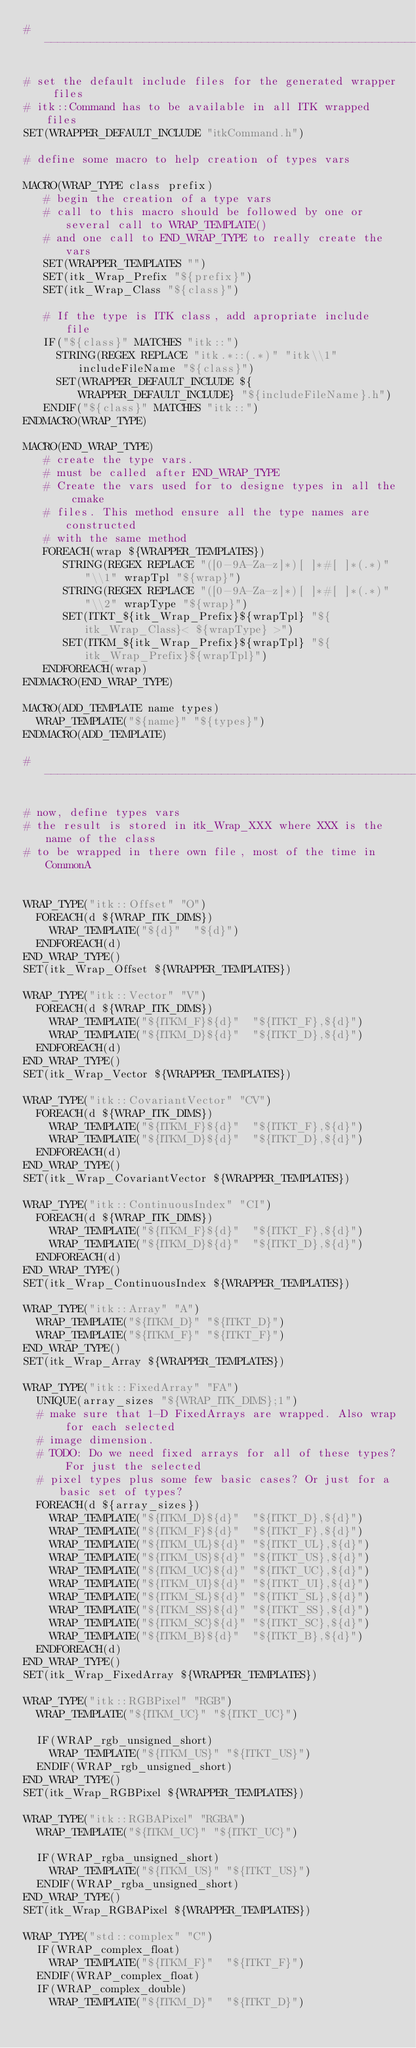Convert code to text. <code><loc_0><loc_0><loc_500><loc_500><_CMake_>#------------------------------------------------------------------------------

# set the default include files for the generated wrapper files
# itk::Command has to be available in all ITK wrapped files
SET(WRAPPER_DEFAULT_INCLUDE "itkCommand.h")

# define some macro to help creation of types vars

MACRO(WRAP_TYPE class prefix)
   # begin the creation of a type vars
   # call to this macro should be followed by one or several call to WRAP_TEMPLATE()
   # and one call to END_WRAP_TYPE to really create the vars
   SET(WRAPPER_TEMPLATES "")
   SET(itk_Wrap_Prefix "${prefix}")
   SET(itk_Wrap_Class "${class}")

   # If the type is ITK class, add apropriate include file
   IF("${class}" MATCHES "itk::")
     STRING(REGEX REPLACE "itk.*::(.*)" "itk\\1" includeFileName "${class}")
     SET(WRAPPER_DEFAULT_INCLUDE ${WRAPPER_DEFAULT_INCLUDE} "${includeFileName}.h")
   ENDIF("${class}" MATCHES "itk::")
ENDMACRO(WRAP_TYPE)

MACRO(END_WRAP_TYPE)
   # create the type vars.
   # must be called after END_WRAP_TYPE
   # Create the vars used for to designe types in all the cmake
   # files. This method ensure all the type names are constructed
   # with the same method
   FOREACH(wrap ${WRAPPER_TEMPLATES})
      STRING(REGEX REPLACE "([0-9A-Za-z]*)[ ]*#[ ]*(.*)" "\\1" wrapTpl "${wrap}")
      STRING(REGEX REPLACE "([0-9A-Za-z]*)[ ]*#[ ]*(.*)" "\\2" wrapType "${wrap}")
      SET(ITKT_${itk_Wrap_Prefix}${wrapTpl} "${itk_Wrap_Class}< ${wrapType} >")
      SET(ITKM_${itk_Wrap_Prefix}${wrapTpl} "${itk_Wrap_Prefix}${wrapTpl}")
   ENDFOREACH(wrap)
ENDMACRO(END_WRAP_TYPE)

MACRO(ADD_TEMPLATE name types)
  WRAP_TEMPLATE("${name}" "${types}")
ENDMACRO(ADD_TEMPLATE)

#------------------------------------------------------------------------------

# now, define types vars
# the result is stored in itk_Wrap_XXX where XXX is the name of the class
# to be wrapped in there own file, most of the time in CommonA


WRAP_TYPE("itk::Offset" "O")
  FOREACH(d ${WRAP_ITK_DIMS})
    WRAP_TEMPLATE("${d}"  "${d}")
  ENDFOREACH(d)
END_WRAP_TYPE()
SET(itk_Wrap_Offset ${WRAPPER_TEMPLATES})

WRAP_TYPE("itk::Vector" "V")
  FOREACH(d ${WRAP_ITK_DIMS})
    WRAP_TEMPLATE("${ITKM_F}${d}"  "${ITKT_F},${d}")
    WRAP_TEMPLATE("${ITKM_D}${d}"  "${ITKT_D},${d}")
  ENDFOREACH(d)
END_WRAP_TYPE()
SET(itk_Wrap_Vector ${WRAPPER_TEMPLATES})

WRAP_TYPE("itk::CovariantVector" "CV")
  FOREACH(d ${WRAP_ITK_DIMS})
    WRAP_TEMPLATE("${ITKM_F}${d}"  "${ITKT_F},${d}")
    WRAP_TEMPLATE("${ITKM_D}${d}"  "${ITKT_D},${d}")
  ENDFOREACH(d)
END_WRAP_TYPE()
SET(itk_Wrap_CovariantVector ${WRAPPER_TEMPLATES})

WRAP_TYPE("itk::ContinuousIndex" "CI")
  FOREACH(d ${WRAP_ITK_DIMS})
    WRAP_TEMPLATE("${ITKM_F}${d}"  "${ITKT_F},${d}")
    WRAP_TEMPLATE("${ITKM_D}${d}"  "${ITKT_D},${d}")
  ENDFOREACH(d)
END_WRAP_TYPE()
SET(itk_Wrap_ContinuousIndex ${WRAPPER_TEMPLATES})

WRAP_TYPE("itk::Array" "A")
  WRAP_TEMPLATE("${ITKM_D}" "${ITKT_D}")
  WRAP_TEMPLATE("${ITKM_F}" "${ITKT_F}")
END_WRAP_TYPE()
SET(itk_Wrap_Array ${WRAPPER_TEMPLATES})

WRAP_TYPE("itk::FixedArray" "FA")
  UNIQUE(array_sizes "${WRAP_ITK_DIMS};1")
  # make sure that 1-D FixedArrays are wrapped. Also wrap for each selected
  # image dimension.
  # TODO: Do we need fixed arrays for all of these types? For just the selected
  # pixel types plus some few basic cases? Or just for a basic set of types?
  FOREACH(d ${array_sizes})
    WRAP_TEMPLATE("${ITKM_D}${d}"  "${ITKT_D},${d}")
    WRAP_TEMPLATE("${ITKM_F}${d}"  "${ITKT_F},${d}")
    WRAP_TEMPLATE("${ITKM_UL}${d}" "${ITKT_UL},${d}")
    WRAP_TEMPLATE("${ITKM_US}${d}" "${ITKT_US},${d}")
    WRAP_TEMPLATE("${ITKM_UC}${d}" "${ITKT_UC},${d}")
    WRAP_TEMPLATE("${ITKM_UI}${d}" "${ITKT_UI},${d}")
    WRAP_TEMPLATE("${ITKM_SL}${d}" "${ITKT_SL},${d}")
    WRAP_TEMPLATE("${ITKM_SS}${d}" "${ITKT_SS},${d}")
    WRAP_TEMPLATE("${ITKM_SC}${d}" "${ITKT_SC},${d}")
    WRAP_TEMPLATE("${ITKM_B}${d}"  "${ITKT_B},${d}")
  ENDFOREACH(d)
END_WRAP_TYPE()
SET(itk_Wrap_FixedArray ${WRAPPER_TEMPLATES})

WRAP_TYPE("itk::RGBPixel" "RGB")
  WRAP_TEMPLATE("${ITKM_UC}" "${ITKT_UC}")
  
  IF(WRAP_rgb_unsigned_short)
    WRAP_TEMPLATE("${ITKM_US}" "${ITKT_US}")
  ENDIF(WRAP_rgb_unsigned_short)
END_WRAP_TYPE()
SET(itk_Wrap_RGBPixel ${WRAPPER_TEMPLATES})

WRAP_TYPE("itk::RGBAPixel" "RGBA")
  WRAP_TEMPLATE("${ITKM_UC}" "${ITKT_UC}")

  IF(WRAP_rgba_unsigned_short)
    WRAP_TEMPLATE("${ITKM_US}" "${ITKT_US}")
  ENDIF(WRAP_rgba_unsigned_short)
END_WRAP_TYPE()
SET(itk_Wrap_RGBAPixel ${WRAPPER_TEMPLATES})

WRAP_TYPE("std::complex" "C")
  IF(WRAP_complex_float)
    WRAP_TEMPLATE("${ITKM_F}"  "${ITKT_F}")
  ENDIF(WRAP_complex_float)
  IF(WRAP_complex_double)
    WRAP_TEMPLATE("${ITKM_D}"  "${ITKT_D}")</code> 